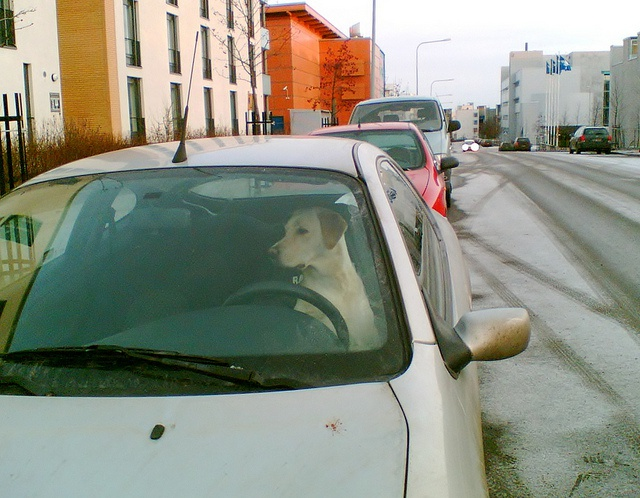Describe the objects in this image and their specific colors. I can see car in darkgreen, darkgray, teal, and black tones, dog in darkgreen, gray, and darkgray tones, car in darkgreen, gray, lightpink, teal, and darkgray tones, car in darkgreen, gray, darkgray, lightblue, and lightgray tones, and car in darkgreen, black, and teal tones in this image. 